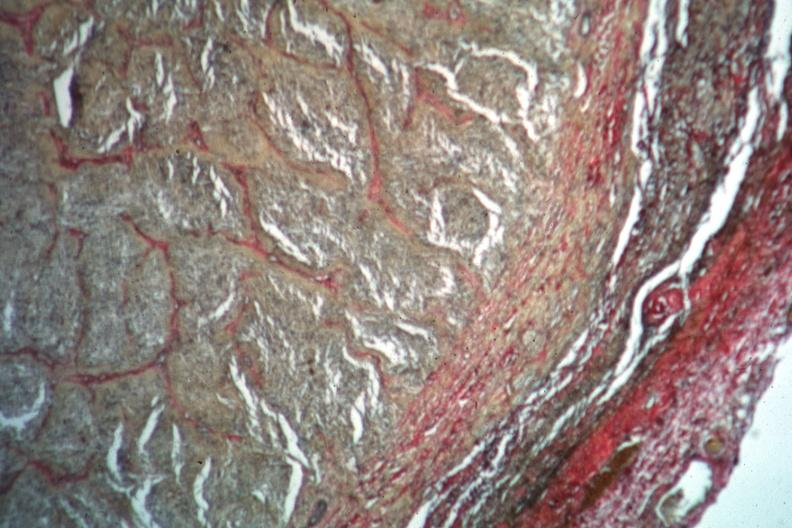what does this image show?
Answer the question using a single word or phrase. Van gieson 